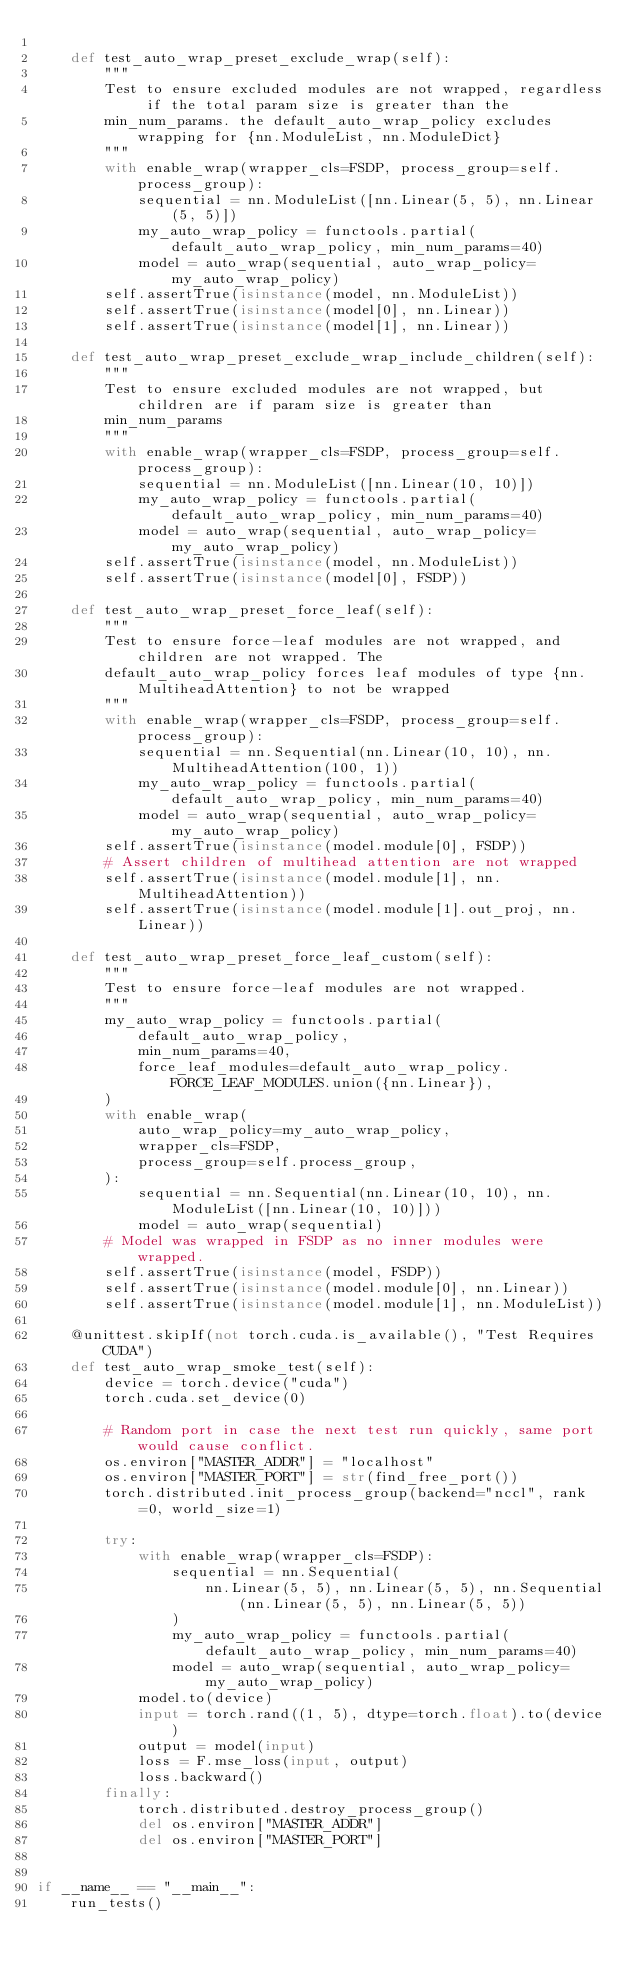<code> <loc_0><loc_0><loc_500><loc_500><_Python_>
    def test_auto_wrap_preset_exclude_wrap(self):
        """
        Test to ensure excluded modules are not wrapped, regardless if the total param size is greater than the
        min_num_params. the default_auto_wrap_policy excludes wrapping for {nn.ModuleList, nn.ModuleDict}
        """
        with enable_wrap(wrapper_cls=FSDP, process_group=self.process_group):
            sequential = nn.ModuleList([nn.Linear(5, 5), nn.Linear(5, 5)])
            my_auto_wrap_policy = functools.partial(default_auto_wrap_policy, min_num_params=40)
            model = auto_wrap(sequential, auto_wrap_policy=my_auto_wrap_policy)
        self.assertTrue(isinstance(model, nn.ModuleList))
        self.assertTrue(isinstance(model[0], nn.Linear))
        self.assertTrue(isinstance(model[1], nn.Linear))

    def test_auto_wrap_preset_exclude_wrap_include_children(self):
        """
        Test to ensure excluded modules are not wrapped, but children are if param size is greater than
        min_num_params
        """
        with enable_wrap(wrapper_cls=FSDP, process_group=self.process_group):
            sequential = nn.ModuleList([nn.Linear(10, 10)])
            my_auto_wrap_policy = functools.partial(default_auto_wrap_policy, min_num_params=40)
            model = auto_wrap(sequential, auto_wrap_policy=my_auto_wrap_policy)
        self.assertTrue(isinstance(model, nn.ModuleList))
        self.assertTrue(isinstance(model[0], FSDP))

    def test_auto_wrap_preset_force_leaf(self):
        """
        Test to ensure force-leaf modules are not wrapped, and children are not wrapped. The
        default_auto_wrap_policy forces leaf modules of type {nn.MultiheadAttention} to not be wrapped
        """
        with enable_wrap(wrapper_cls=FSDP, process_group=self.process_group):
            sequential = nn.Sequential(nn.Linear(10, 10), nn.MultiheadAttention(100, 1))
            my_auto_wrap_policy = functools.partial(default_auto_wrap_policy, min_num_params=40)
            model = auto_wrap(sequential, auto_wrap_policy=my_auto_wrap_policy)
        self.assertTrue(isinstance(model.module[0], FSDP))
        # Assert children of multihead attention are not wrapped
        self.assertTrue(isinstance(model.module[1], nn.MultiheadAttention))
        self.assertTrue(isinstance(model.module[1].out_proj, nn.Linear))

    def test_auto_wrap_preset_force_leaf_custom(self):
        """
        Test to ensure force-leaf modules are not wrapped.
        """
        my_auto_wrap_policy = functools.partial(
            default_auto_wrap_policy,
            min_num_params=40,
            force_leaf_modules=default_auto_wrap_policy.FORCE_LEAF_MODULES.union({nn.Linear}),
        )
        with enable_wrap(
            auto_wrap_policy=my_auto_wrap_policy,
            wrapper_cls=FSDP,
            process_group=self.process_group,
        ):
            sequential = nn.Sequential(nn.Linear(10, 10), nn.ModuleList([nn.Linear(10, 10)]))
            model = auto_wrap(sequential)
        # Model was wrapped in FSDP as no inner modules were wrapped.
        self.assertTrue(isinstance(model, FSDP))
        self.assertTrue(isinstance(model.module[0], nn.Linear))
        self.assertTrue(isinstance(model.module[1], nn.ModuleList))

    @unittest.skipIf(not torch.cuda.is_available(), "Test Requires CUDA")
    def test_auto_wrap_smoke_test(self):
        device = torch.device("cuda")
        torch.cuda.set_device(0)

        # Random port in case the next test run quickly, same port would cause conflict.
        os.environ["MASTER_ADDR"] = "localhost"
        os.environ["MASTER_PORT"] = str(find_free_port())
        torch.distributed.init_process_group(backend="nccl", rank=0, world_size=1)

        try:
            with enable_wrap(wrapper_cls=FSDP):
                sequential = nn.Sequential(
                    nn.Linear(5, 5), nn.Linear(5, 5), nn.Sequential(nn.Linear(5, 5), nn.Linear(5, 5))
                )
                my_auto_wrap_policy = functools.partial(default_auto_wrap_policy, min_num_params=40)
                model = auto_wrap(sequential, auto_wrap_policy=my_auto_wrap_policy)
            model.to(device)
            input = torch.rand((1, 5), dtype=torch.float).to(device)
            output = model(input)
            loss = F.mse_loss(input, output)
            loss.backward()
        finally:
            torch.distributed.destroy_process_group()
            del os.environ["MASTER_ADDR"]
            del os.environ["MASTER_PORT"]


if __name__ == "__main__":
    run_tests()
</code> 